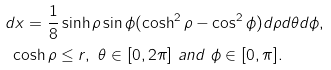<formula> <loc_0><loc_0><loc_500><loc_500>& d x = \frac { 1 } { 8 } \sinh \rho \sin \phi ( \cosh ^ { 2 } \rho - \cos ^ { 2 } \phi ) d \rho d \theta d \phi , \\ & \ \cosh \rho \leq r , \ \theta \in [ 0 , 2 \pi ] \ a n d \ \phi \in [ 0 , \pi ] .</formula> 